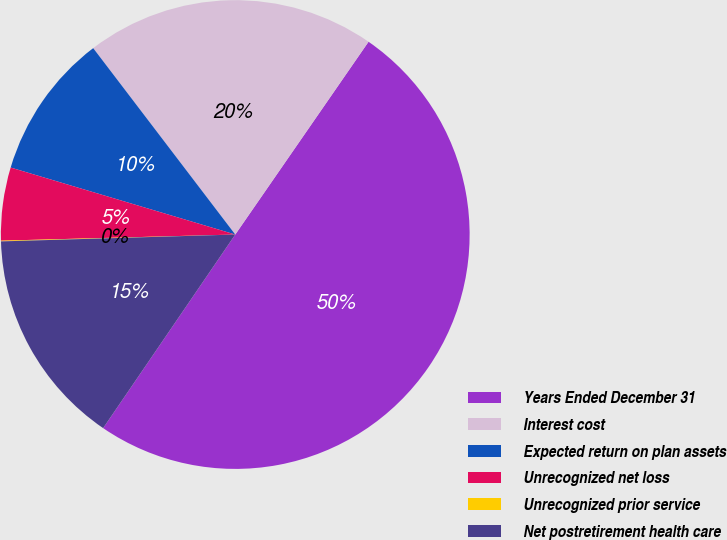Convert chart to OTSL. <chart><loc_0><loc_0><loc_500><loc_500><pie_chart><fcel>Years Ended December 31<fcel>Interest cost<fcel>Expected return on plan assets<fcel>Unrecognized net loss<fcel>Unrecognized prior service<fcel>Net postretirement health care<nl><fcel>49.9%<fcel>19.99%<fcel>10.02%<fcel>5.03%<fcel>0.05%<fcel>15.0%<nl></chart> 